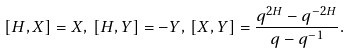Convert formula to latex. <formula><loc_0><loc_0><loc_500><loc_500>[ H , X ] = X , \, [ H , Y ] = - Y , \, [ X , Y ] = \frac { q ^ { 2 H } - q ^ { - 2 H } } { q - q ^ { - 1 } } .</formula> 